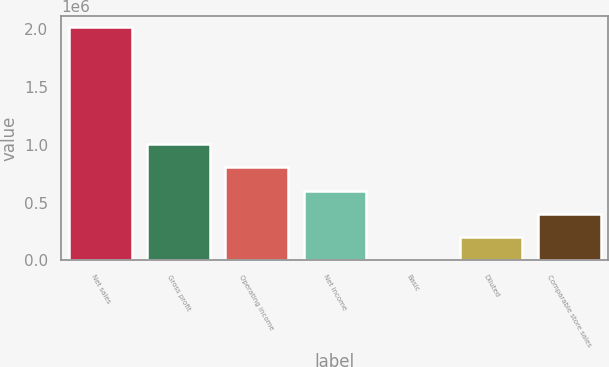<chart> <loc_0><loc_0><loc_500><loc_500><bar_chart><fcel>Net sales<fcel>Gross profit<fcel>Operating income<fcel>Net income<fcel>Basic<fcel>Diluted<fcel>Comparable store sales<nl><fcel>2.01776e+06<fcel>1.00888e+06<fcel>807106<fcel>605329<fcel>1.25<fcel>201777<fcel>403553<nl></chart> 